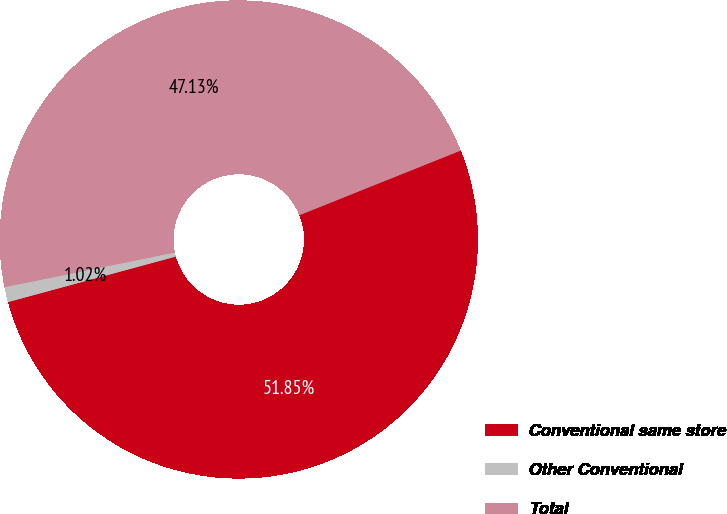<chart> <loc_0><loc_0><loc_500><loc_500><pie_chart><fcel>Conventional same store<fcel>Other Conventional<fcel>Total<nl><fcel>51.85%<fcel>1.02%<fcel>47.13%<nl></chart> 